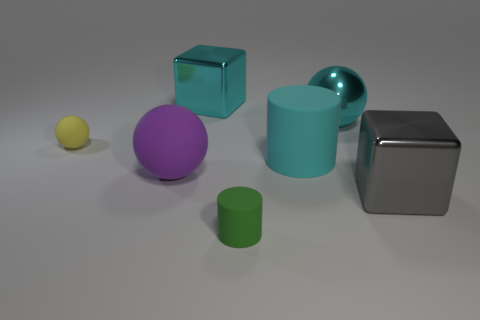The green object has what shape?
Ensure brevity in your answer.  Cylinder. What is the ball that is to the right of the cylinder in front of the large metal block to the right of the cyan metal sphere made of?
Provide a succinct answer. Metal. What number of other things are there of the same material as the big purple sphere
Your answer should be very brief. 3. There is a large purple ball that is left of the green rubber thing; how many cyan matte objects are in front of it?
Your response must be concise. 0. How many cubes are either small green objects or big metallic objects?
Offer a terse response. 2. There is a big object that is both in front of the large cyan cylinder and to the right of the big purple rubber ball; what color is it?
Provide a short and direct response. Gray. Is there anything else that is the same color as the big cylinder?
Offer a very short reply. Yes. There is a metallic block in front of the large cyan metallic thing that is behind the cyan metallic ball; what is its color?
Offer a very short reply. Gray. Do the gray metallic thing and the cyan rubber thing have the same size?
Give a very brief answer. Yes. Do the big block behind the large cyan cylinder and the cube in front of the tiny yellow thing have the same material?
Your answer should be compact. Yes. 